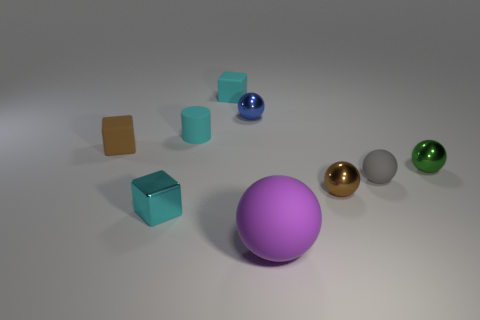Is the number of metal spheres less than the number of tiny spheres?
Give a very brief answer. Yes. Are there any gray rubber balls that have the same size as the green metal sphere?
Provide a short and direct response. Yes. Is the shape of the small brown rubber thing the same as the cyan shiny object that is to the left of the gray object?
Offer a very short reply. Yes. How many cylinders are either blue metallic objects or small brown matte things?
Your answer should be very brief. 0. What is the color of the large sphere?
Provide a succinct answer. Purple. Are there more large purple balls than cyan cubes?
Offer a terse response. No. What number of objects are either small matte cylinders left of the purple matte thing or purple rubber balls?
Your answer should be very brief. 2. Does the blue ball have the same material as the brown cube?
Ensure brevity in your answer.  No. What size is the brown metallic thing that is the same shape as the small green metal thing?
Make the answer very short. Small. There is a small brown thing to the right of the big thing; is its shape the same as the cyan object in front of the tiny brown matte thing?
Ensure brevity in your answer.  No. 